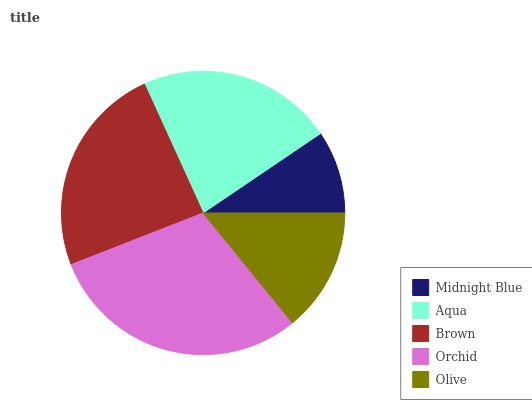Is Midnight Blue the minimum?
Answer yes or no. Yes. Is Orchid the maximum?
Answer yes or no. Yes. Is Aqua the minimum?
Answer yes or no. No. Is Aqua the maximum?
Answer yes or no. No. Is Aqua greater than Midnight Blue?
Answer yes or no. Yes. Is Midnight Blue less than Aqua?
Answer yes or no. Yes. Is Midnight Blue greater than Aqua?
Answer yes or no. No. Is Aqua less than Midnight Blue?
Answer yes or no. No. Is Aqua the high median?
Answer yes or no. Yes. Is Aqua the low median?
Answer yes or no. Yes. Is Brown the high median?
Answer yes or no. No. Is Olive the low median?
Answer yes or no. No. 